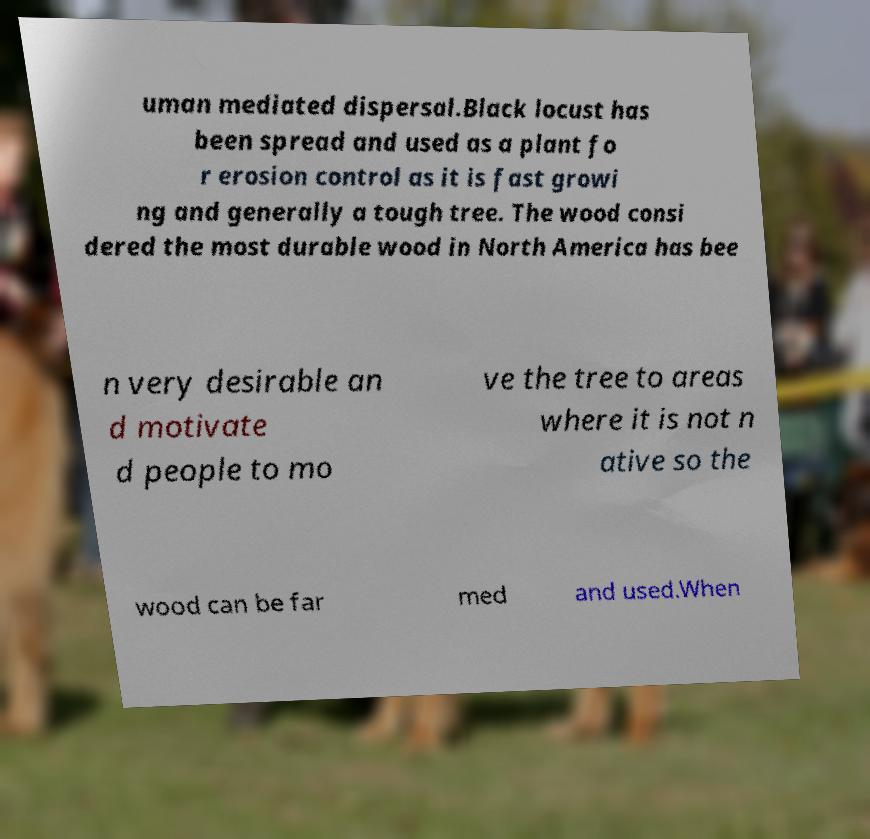For documentation purposes, I need the text within this image transcribed. Could you provide that? uman mediated dispersal.Black locust has been spread and used as a plant fo r erosion control as it is fast growi ng and generally a tough tree. The wood consi dered the most durable wood in North America has bee n very desirable an d motivate d people to mo ve the tree to areas where it is not n ative so the wood can be far med and used.When 